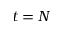Convert formula to latex. <formula><loc_0><loc_0><loc_500><loc_500>t = N</formula> 